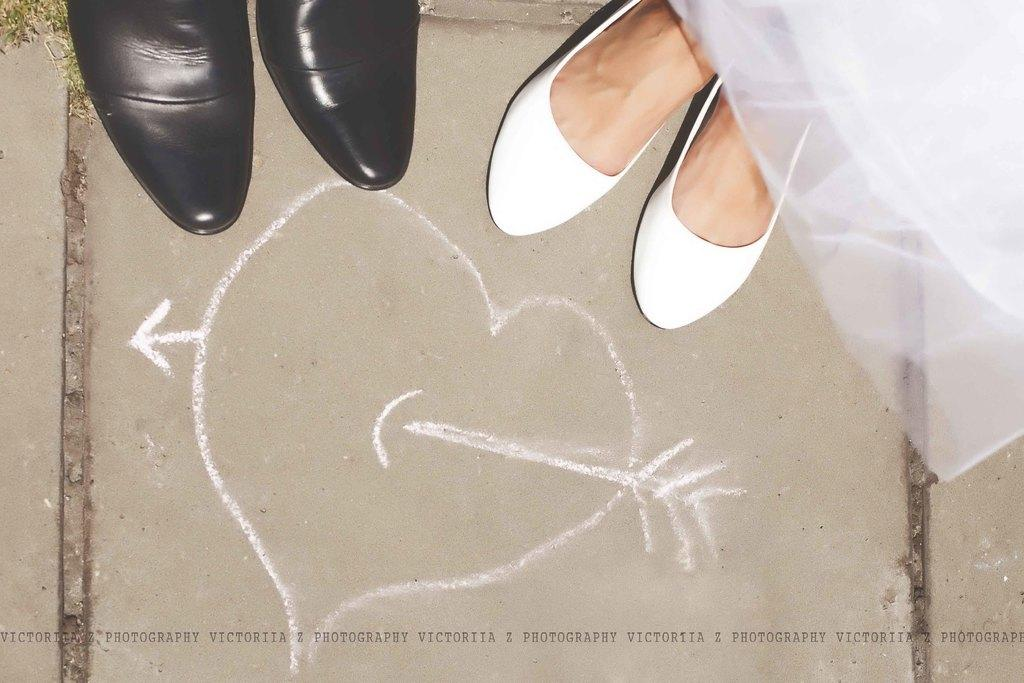What body part can be seen in the image? Human legs are visible in the image. What type of clothing is present in the image? There is a frock in the image. What type of surface is on the floor in the image? Grass is present on the floor in the image. What type of soap is being used to extinguish the fire in the image? There is no fire or soap present in the image. 